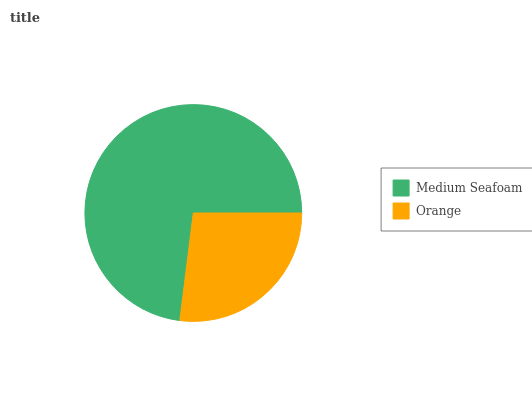Is Orange the minimum?
Answer yes or no. Yes. Is Medium Seafoam the maximum?
Answer yes or no. Yes. Is Orange the maximum?
Answer yes or no. No. Is Medium Seafoam greater than Orange?
Answer yes or no. Yes. Is Orange less than Medium Seafoam?
Answer yes or no. Yes. Is Orange greater than Medium Seafoam?
Answer yes or no. No. Is Medium Seafoam less than Orange?
Answer yes or no. No. Is Medium Seafoam the high median?
Answer yes or no. Yes. Is Orange the low median?
Answer yes or no. Yes. Is Orange the high median?
Answer yes or no. No. Is Medium Seafoam the low median?
Answer yes or no. No. 